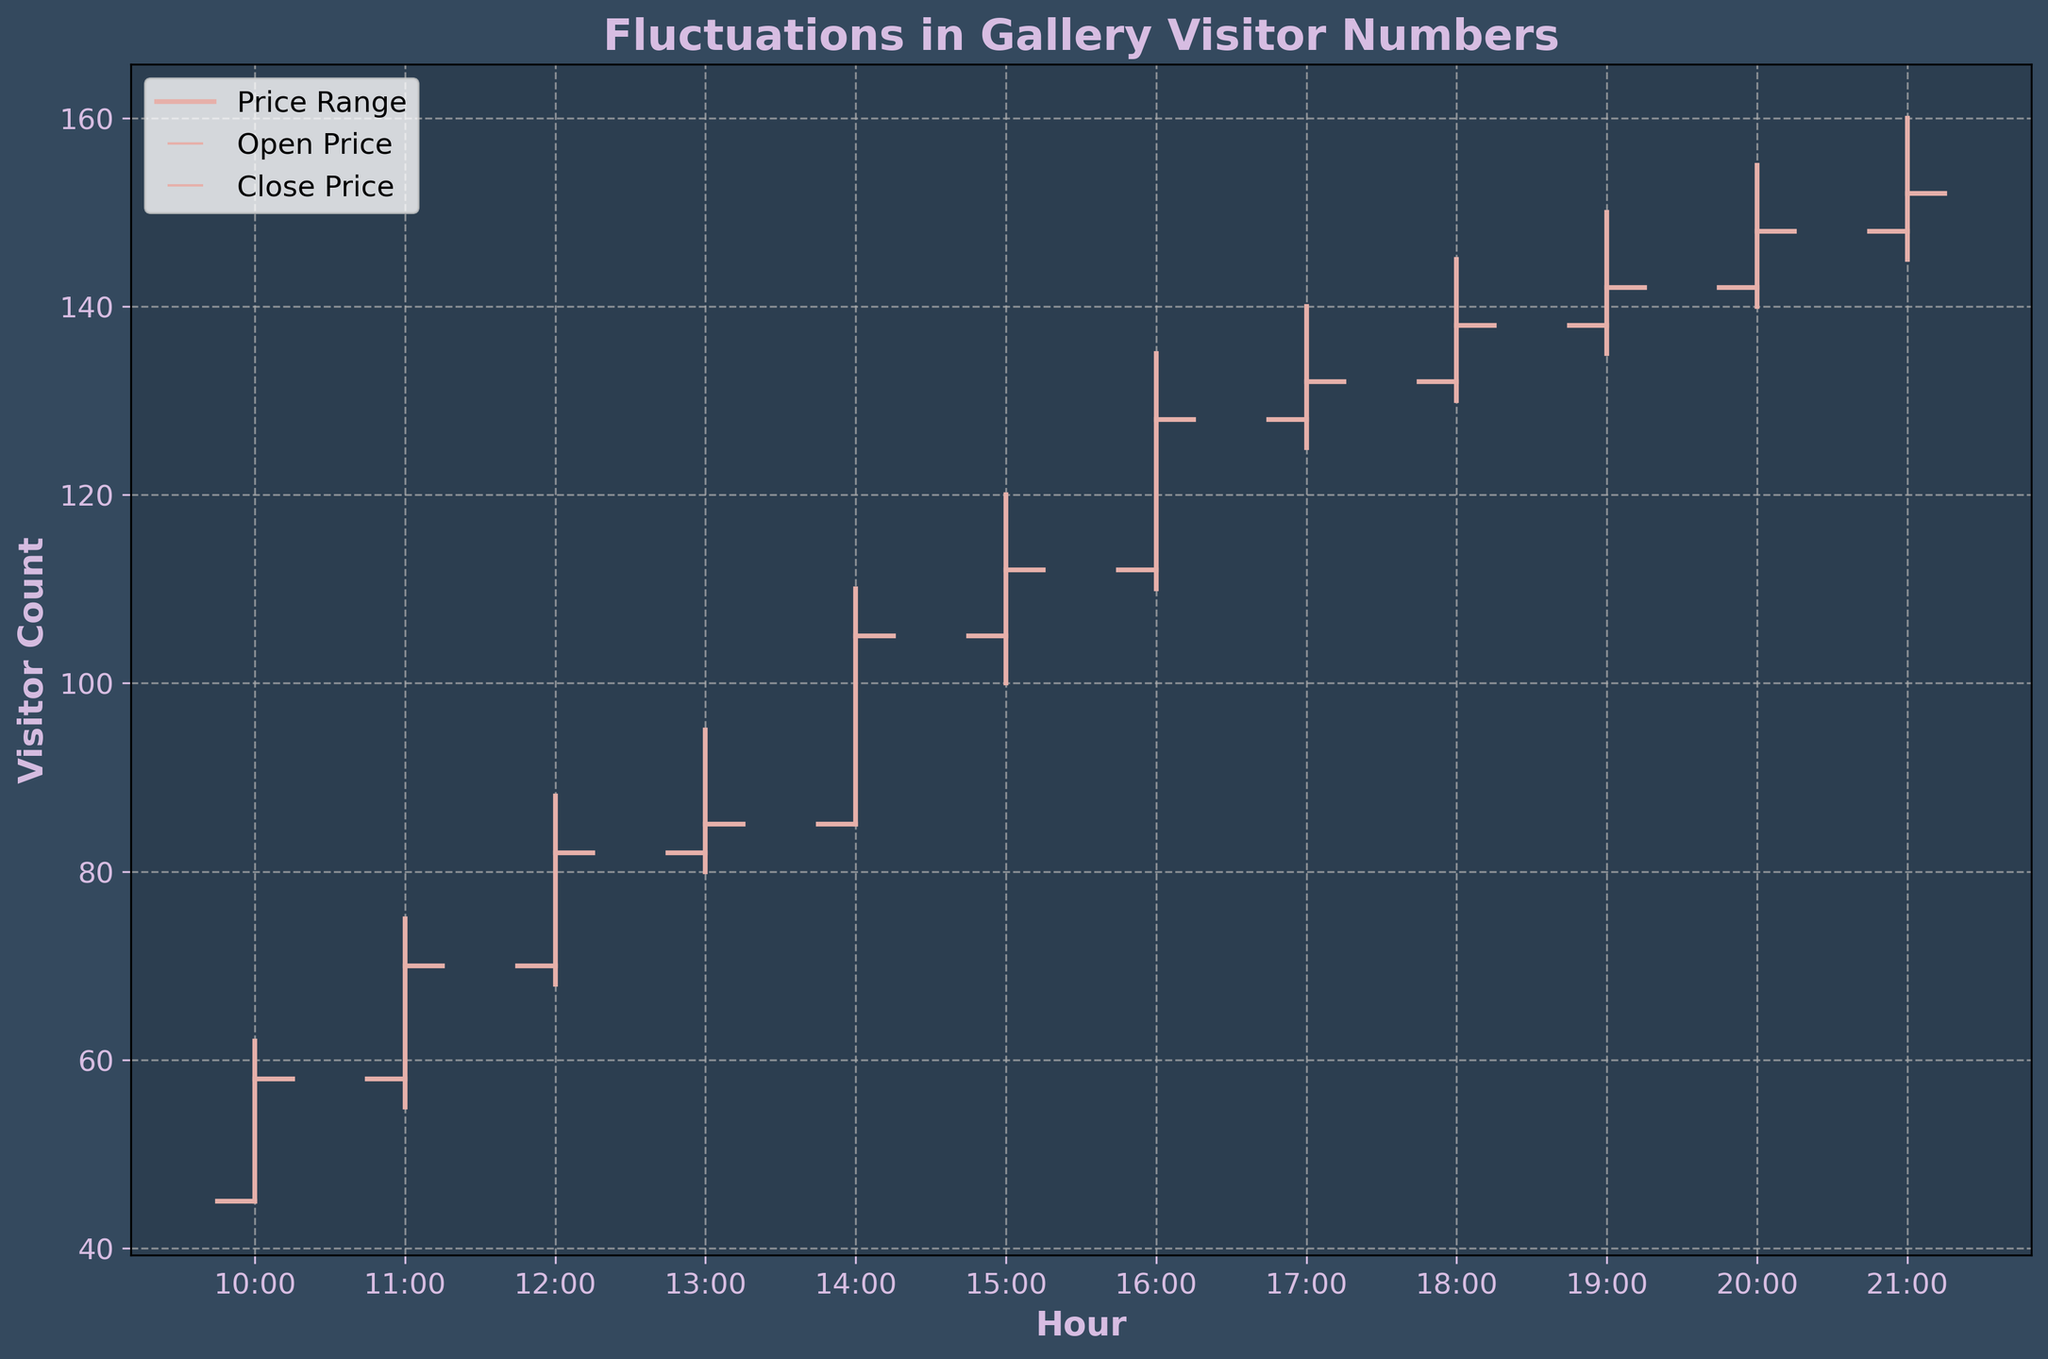What is the title of the chart? The title of the chart is placed at the top and is large and bold. It reads, "Fluctuations in Gallery Visitor Numbers".
Answer: Fluctuations in Gallery Visitor Numbers What are the axis labels in the chart? The x-axis label reads "Hour" and the y-axis label reads "Visitor Count". Both are written in bold and distinct colors.
Answer: Hour, Visitor Count How many data points are plotted in this OHLC chart? There are hourly data points starting from 10:00 AM to 9:00 PM, making a total of 12 data points.
Answer: 12 What was the highest visitor count recorded during the exhibition? By looking at the highest points on the vertical lines, the maximum visitor count recorded was 160 at 9:00 PM.
Answer: 160 At what hour did the visitor count reach its lowest value, and what was that value? The lowest visitor count was at 10:00 AM, as visible by the minimum of the vertical lines. The lowest value was 45 visitors.
Answer: 10:00 AM, 45 By how much did the visitor count increase between 12:00 PM and 1:00 PM? The close value at 12:00 PM is 82, and the close value at 1:00 PM is 85. The increase is calculated as 85 - 82.
Answer: 3 What is the average closing visitor count between 10:00 AM and 1:00 PM? The closing values between 10:00 AM and 1:00 PM are 58, 70, 82, and 85. The average is calculated as (58 + 70 + 82 + 85) / 4.
Answer: 73.75 Which hour had the smallest range between high and low visitor counts? The range is found by subtracting the low from the high for each hour. The smallest range is at 1:00 PM, where the high is 95 and the low is 80, giving a range of 15.
Answer: 1:00 PM What trend can you observe about the visitor count from 10:00 AM to 9:00 PM? Generally, the visitor count increases steadily throughout the day, reaching its peak towards the evening hours.
Answer: Increasing trend How does the visitor count at the open of the exhibition hour at 3:00 PM compare to the closing count at the previous hour? The open count at 3:00 PM is 105, while the close count at 2:00 PM is also 105. They are equal.
Answer: Equal 